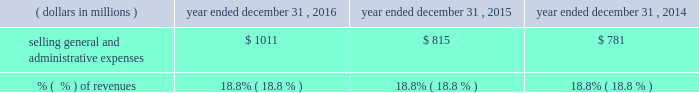2015 compared to 2014 when compared to 2014 , costs of revenue in 2015 increased $ 41 million .
This increase included a constant currency increase in expenses of approximately $ 238 million , or 8.9% ( 8.9 % ) , partially offset by a positive impact of approximately $ 197 million from the effects of foreign currency fluctuations .
The constant currency growth was comprised of a $ 71 million increase in commercial solutions , which included the impact from the encore acquisition which closed in july 2014 , a $ 146 million increase in research & development solutions , which included the incremental impact from the businesses that quest contributed to q2 solutions , and a $ 21 million increase in integrated engagement services .
The decrease in costs of revenue as a percent of revenues for 2015 was primarily as a result of an improvement in constant currency profit margin in the commercial solutions , research & development solutions and integrated engagement services segments ( as more fully described in the segment discussion later in this section ) .
For 2015 , this constant currency profit margin expansion was partially offset by the effect from a higher proportion of consolidated revenues being contributed by our lower margin integrated engagement services segment when compared to 2014 as well as a negative impact from foreign currency fluctuations .
Selling , general and administrative expenses , exclusive of depreciation and amortization .
2016 compared to 2015 the $ 196 million increase in selling , general and administrative expenses in 2016 included a constant currency increase of $ 215 million , or 26.4% ( 26.4 % ) , partially offset by a positive impact of approximately $ 19 million from the effects of foreign currency fluctuations .
The constant currency growth was comprised of a $ 151 million increase in commercial solutions , which includes $ 158 million from the merger with ims health , partially offset by a decline in the legacy service offerings , a $ 32 million increase in research & development solutions , which includes the incremental impact from the businesses that quest contributed to q2 solutions , a $ 3 million increase in integrated engagement services , and a $ 29 million increase in general corporate and unallocated expenses , which includes $ 37 million from the merger with ims health .
The constant currency increase in general corporate and unallocated expenses in 2016 was primarily due to higher stock-based compensation expense .
2015 compared to 2014 the $ 34 million increase in selling , general and administrative expenses in 2015 included a constant currency increase of $ 74 million , or 9.5% ( 9.5 % ) , partially offset by a positive impact of approximately $ 42 million from the effects of foreign currency fluctuations .
The constant currency growth was comprised of a $ 14 million increase in commercial solutions , which included the impact from the encore acquisition which closed in july 2014 , a $ 40 million increase in research & development solutions , which included the incremental impact from the businesses that quest contributed to q2 solutions , a $ 4 million increase in integrated engagement services , and a $ 14 million increase in general corporate and unallocated expenses .
The constant currency increase in general corporate and unallocated expenses in 2015 was primarily due to higher stock-based compensation expense and costs associated with the q2 solutions transaction. .
What was the gross revenues in 2016 based on the percent of the selling general and administrative expenses? 
Computations: (1011 / 18.8%)
Answer: 5377.65957. 